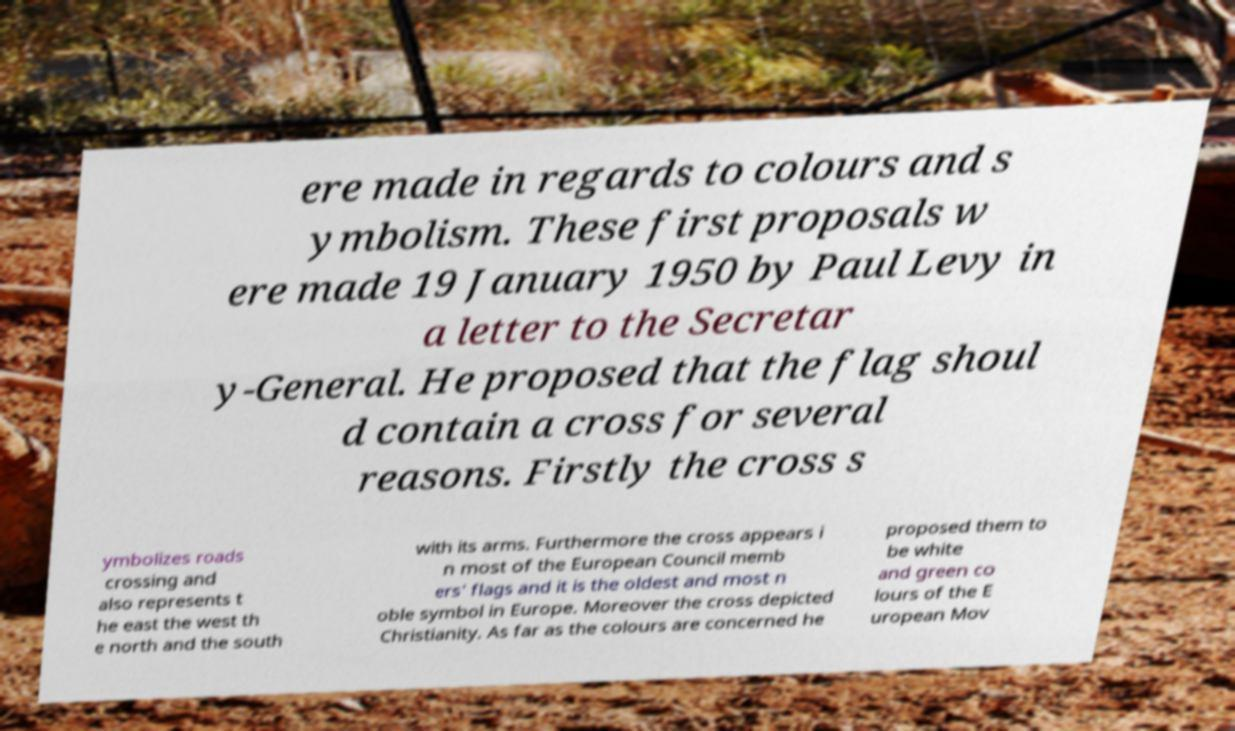Could you extract and type out the text from this image? ere made in regards to colours and s ymbolism. These first proposals w ere made 19 January 1950 by Paul Levy in a letter to the Secretar y-General. He proposed that the flag shoul d contain a cross for several reasons. Firstly the cross s ymbolizes roads crossing and also represents t he east the west th e north and the south with its arms. Furthermore the cross appears i n most of the European Council memb ers' flags and it is the oldest and most n oble symbol in Europe. Moreover the cross depicted Christianity. As far as the colours are concerned he proposed them to be white and green co lours of the E uropean Mov 